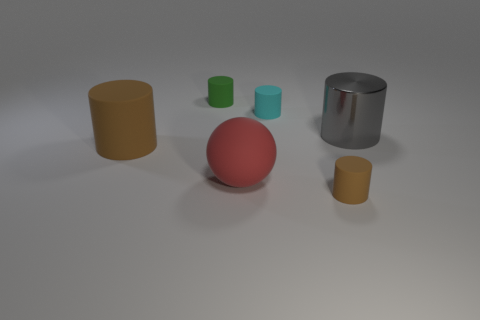Add 1 large cyan blocks. How many objects exist? 7 Subtract all large cylinders. How many cylinders are left? 3 Subtract all red balls. How many yellow cylinders are left? 0 Add 3 large red cylinders. How many large red cylinders exist? 3 Subtract all cyan cylinders. How many cylinders are left? 4 Subtract 0 yellow cylinders. How many objects are left? 6 Subtract all cylinders. How many objects are left? 1 Subtract 1 spheres. How many spheres are left? 0 Subtract all purple cylinders. Subtract all cyan balls. How many cylinders are left? 5 Subtract all small green cylinders. Subtract all small green rubber cylinders. How many objects are left? 4 